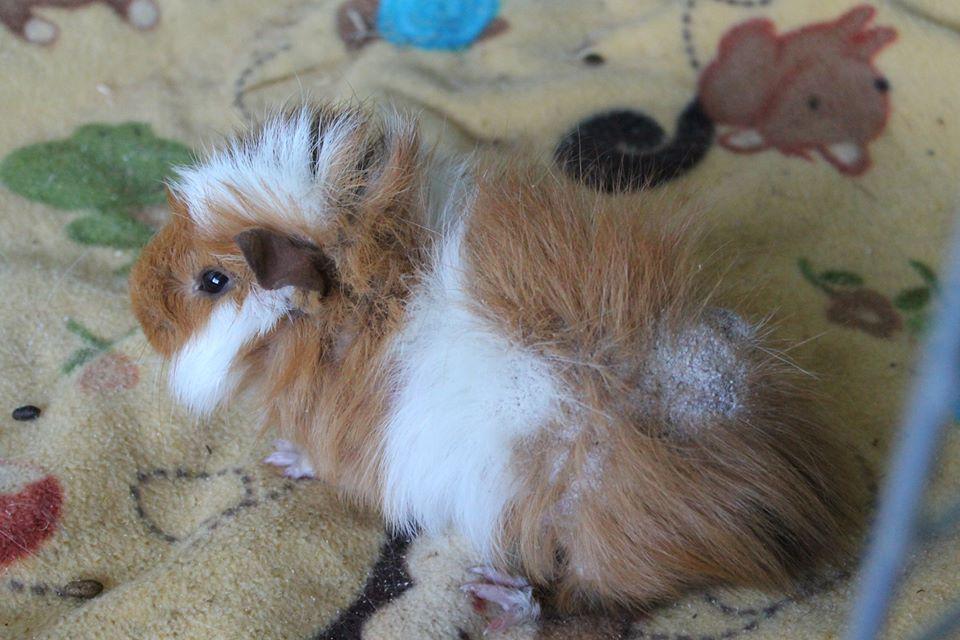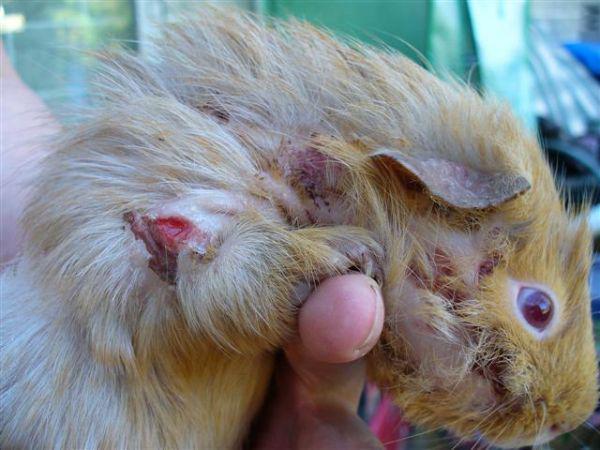The first image is the image on the left, the second image is the image on the right. Assess this claim about the two images: "One images shows only one guinea pig and the other shows at least two.". Correct or not? Answer yes or no. No. The first image is the image on the left, the second image is the image on the right. Assess this claim about the two images: "No image contains more than two guinea pigs, and one image features two multi-color guinea pigs posed side-by-side and facing straight ahead.". Correct or not? Answer yes or no. No. 